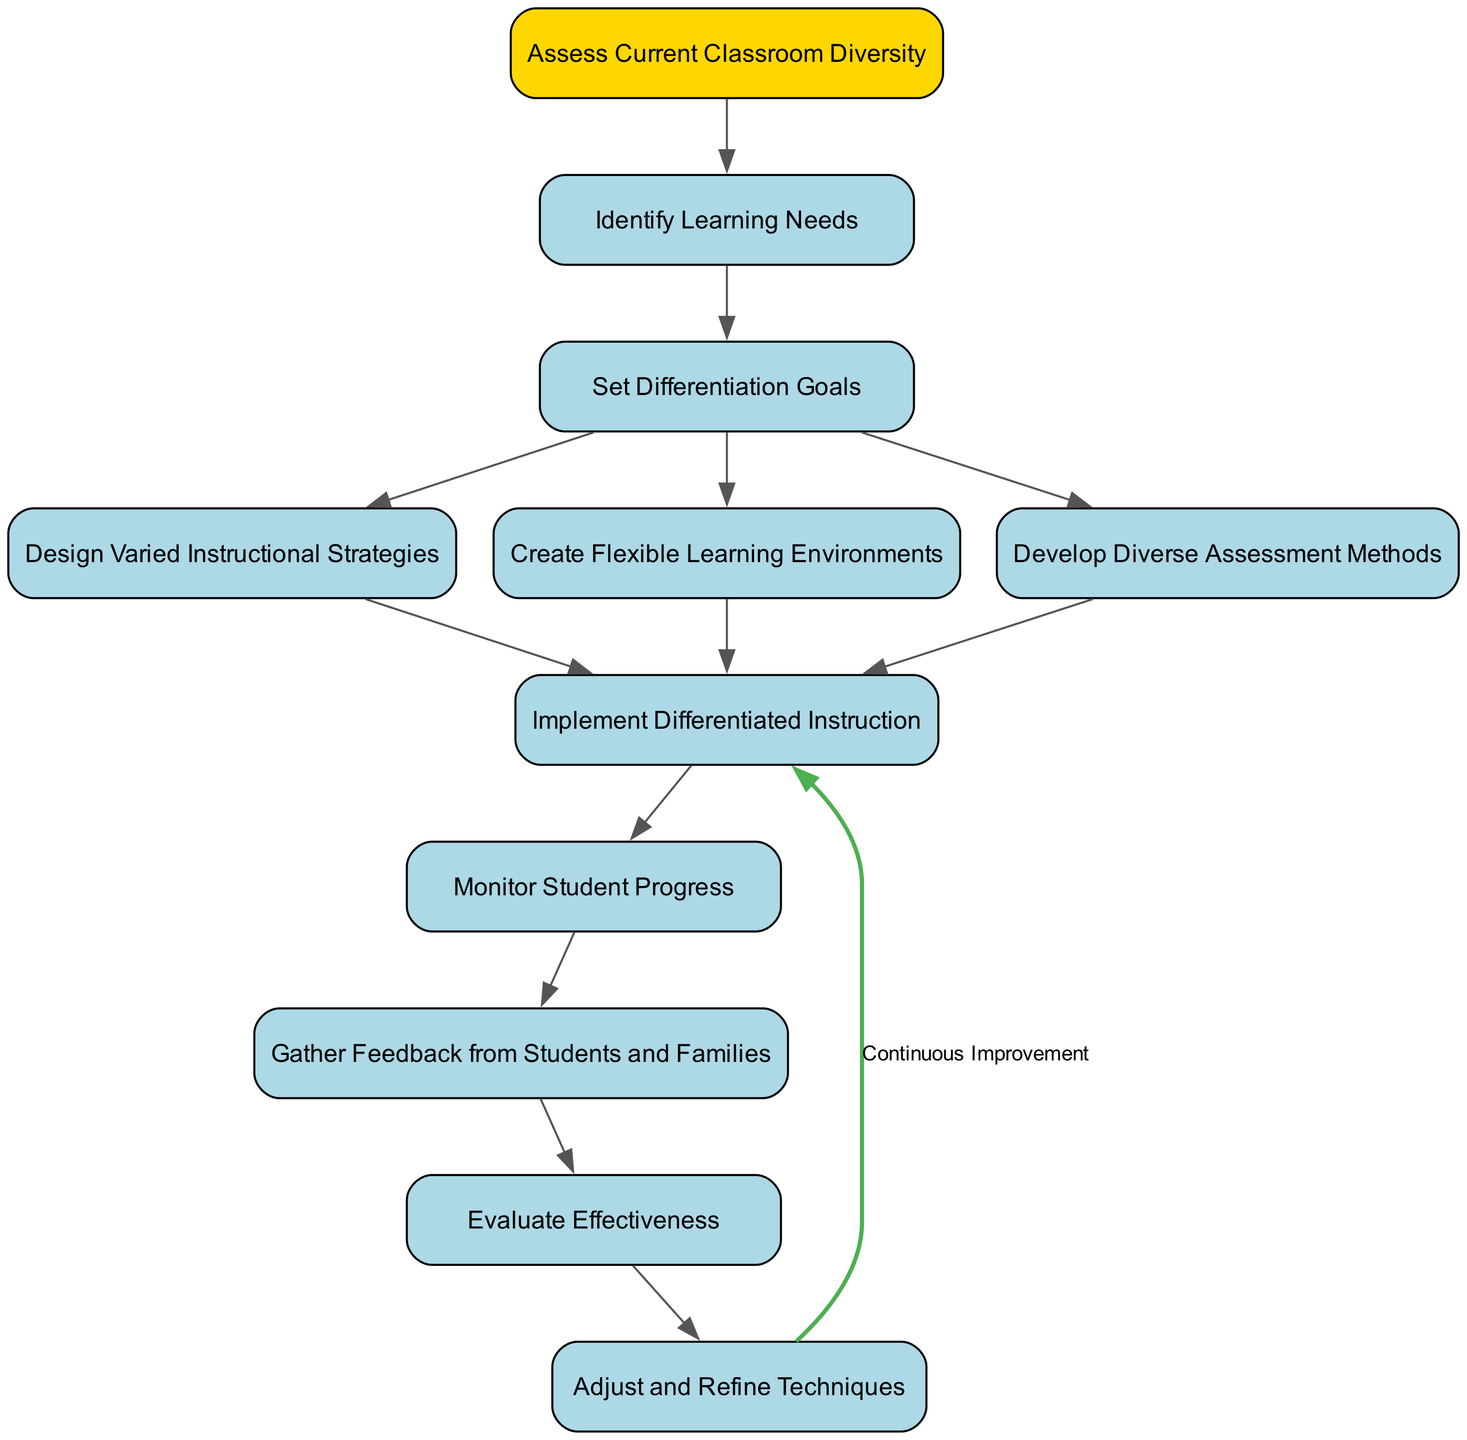What is the first step in the flowchart? The flowchart starts with the node "Assess Current Classroom Diversity", which is the first step in the process outlined.
Answer: Assess Current Classroom Diversity How many nodes are in the flowchart? By counting all the nodes, including the start node and subsequent steps, we find there are a total of ten nodes represented in the flowchart.
Answer: 10 Which node follows "Set Differentiation Goals"? After "Set Differentiation Goals", the flowchart shows three nodes branching out: "Design Varied Instructional Strategies", "Create Flexible Learning Environments", and "Develop Diverse Assessment Methods".
Answer: Design Varied Instructional Strategies, Create Flexible Learning Environments, Develop Diverse Assessment Methods What is the connection between "Monitor Student Progress" and "Gather Feedback from Students and Families"? The diagram indicates a direct connection from "Monitor Student Progress" to "Gather Feedback from Students and Families", indicating that feedback collection occurs after monitoring.
Answer: Direct connection What label is associated with the edge going from "Adjust and Refine Techniques" to "Implement Differentiated Instruction"? The edge that connects "Adjust and Refine Techniques" to "Implement Differentiated Instruction" carries the label "Continuous Improvement", which emphasizes the iterative nature of the process.
Answer: Continuous Improvement How is effectiveness evaluated in the process outlined in the flowchart? The flowchart indicates that effectiveness is evaluated after gathering feedback from both students and families, which provides insights into the instructional strategies' impact.
Answer: Gather Feedback from Students and Families Which node is directly prior to "Evaluate Effectiveness"? The diagram shows that "Gather Feedback from Students and Families" is the direct predecessor to "Evaluate Effectiveness" in the flowchart's progression.
Answer: Gather Feedback from Students and Families What is the last node in the diagram's flow? The final node in the flowchart, which indicates the end of the outlined process after adjustments, is "Adjust and Refine Techniques".
Answer: Adjust and Refine Techniques 